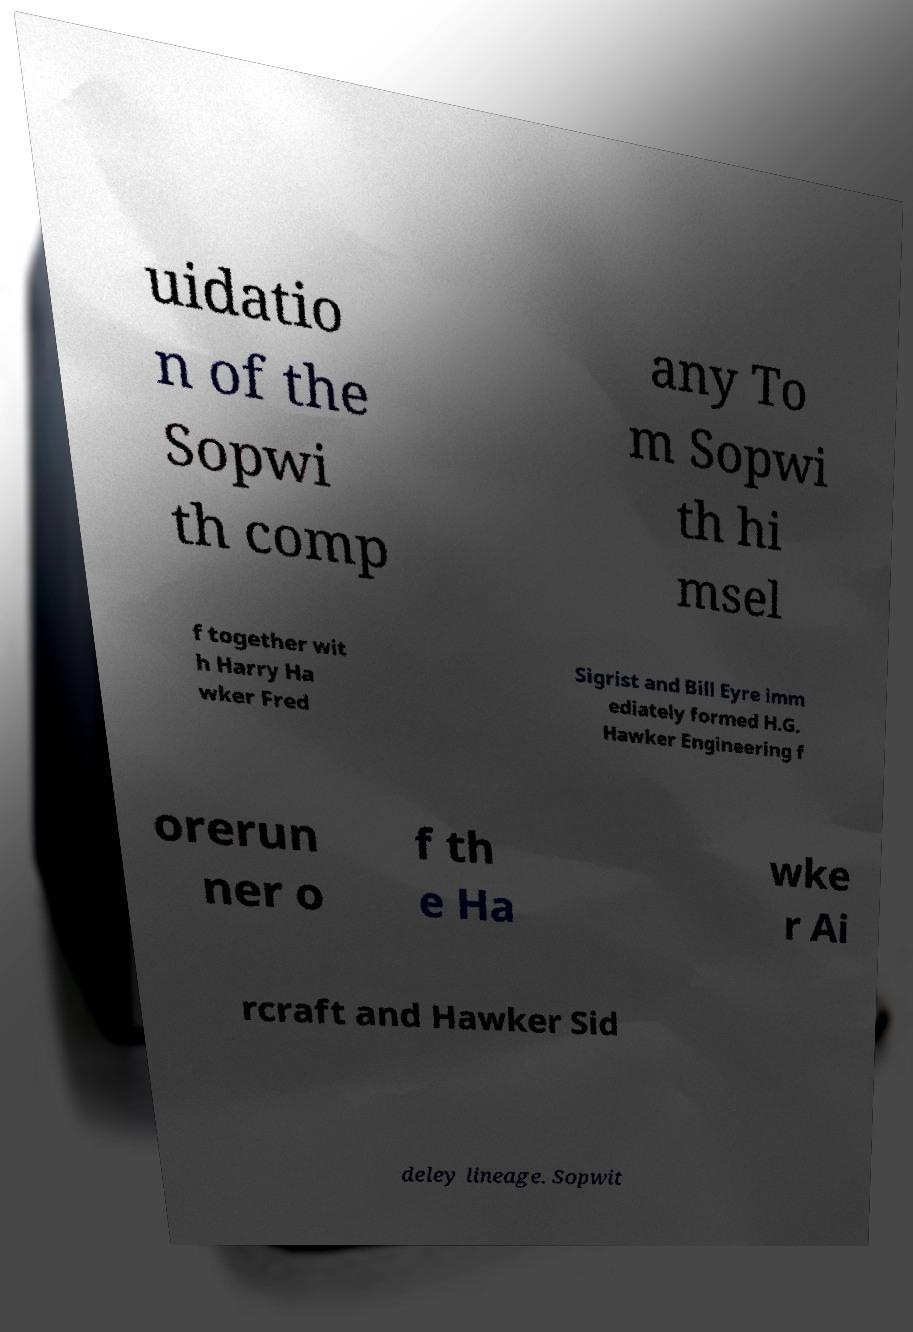Could you extract and type out the text from this image? uidatio n of the Sopwi th comp any To m Sopwi th hi msel f together wit h Harry Ha wker Fred Sigrist and Bill Eyre imm ediately formed H.G. Hawker Engineering f orerun ner o f th e Ha wke r Ai rcraft and Hawker Sid deley lineage. Sopwit 